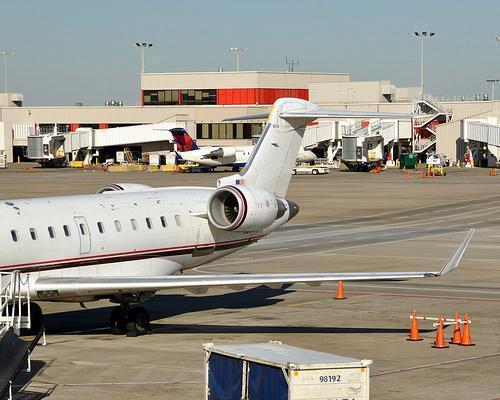How many planes can you see?
Give a very brief answer. 1. 